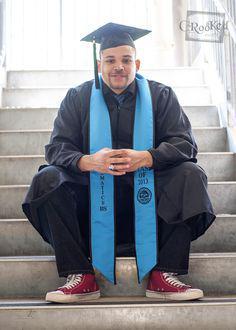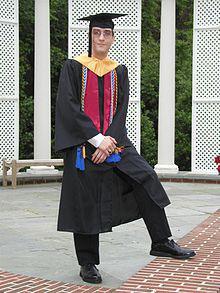The first image is the image on the left, the second image is the image on the right. Assess this claim about the two images: "One picture shows someone from the back side.". Correct or not? Answer yes or no. No. The first image is the image on the left, the second image is the image on the right. Examine the images to the left and right. Is the description "a person is facing away from the camera with a light colored sash hanging down their back" accurate? Answer yes or no. No. 